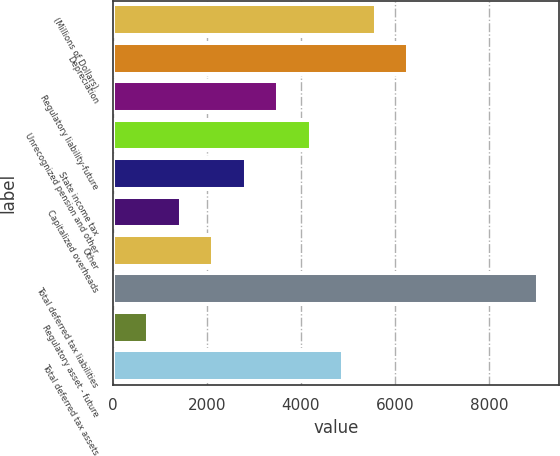Convert chart to OTSL. <chart><loc_0><loc_0><loc_500><loc_500><bar_chart><fcel>(Millions of Dollars)<fcel>Depreciation<fcel>Regulatory liability-future<fcel>Unrecognized pension and other<fcel>State income tax<fcel>Capitalized overheads<fcel>Other<fcel>Total deferred tax liabilities<fcel>Regulatory asset - future<fcel>Total deferred tax assets<nl><fcel>5591<fcel>6282<fcel>3518<fcel>4209<fcel>2827<fcel>1445<fcel>2136<fcel>9046<fcel>754<fcel>4900<nl></chart> 